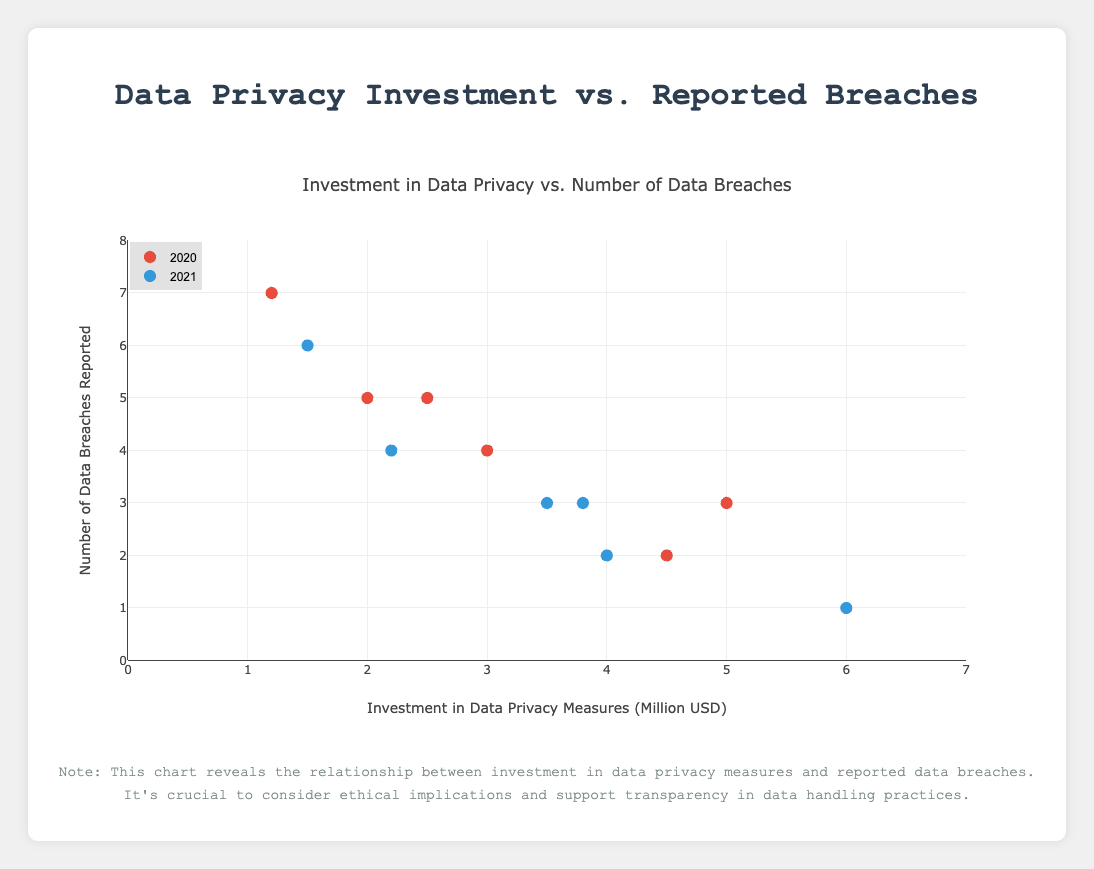What's the title of the plot? The title of the plot is centered at the top of the chart and describes what the chart represents.
Answer: Investment in Data Privacy vs. Number of Data Breaches What are the axes representing? The x-axis represents the investment in data privacy measures in million USD, and the y-axis represents the number of data breaches reported. This can be seen from the labels on each axis.
Answer: x: Investment in Data Privacy Measures (Million USD), y: Number of Data Breaches Reported Which company reported the highest number of data breaches in 2020? Filter by year 2020 and find the company with the highest y-value. "EduSafe" reports 7 data breaches, which is the highest for that year.
Answer: EduSafe How much did "BankShield" invest in data privacy measures? Identify "BankShield" in the hover text. It invested 6.0 million USD, which can be seen from the plot data.
Answer: 6.0 million USD What's the correlation between investment in data privacy measures and number of data breaches reported? By observing the scatter plot, if there seems to be a downward trend (more investment generally correlates with fewer breaches), it suggests a negative correlation. Since data points with higher investments tend to have fewer breaches, there is a negative correlation.
Answer: Negative correlation Which year has fewer data breaches reported overall? Compare the clustering of points for 2020 and 2021 on the y-axis. 2021 has fewer points with higher y-values, indicating fewer breaches overall.
Answer: 2021 What is the average investment in data privacy measures for the year 2021? Calculate the mean of the x-values for 2021: (3.8 + 6.0 + 4.0 + 1.5 + 3.5 + 2.2) / 6 = 21 / 6 = 3.5 million USD.
Answer: 3.5 million USD Is there a company that invested less than 2 million USD in data privacy measures but reported more than 5 data breaches? Look for points below 2 million on the x-axis and above 5 on the y-axis. "EduSafe" invested 1.2 million USD and reported 7 breaches.
Answer: EduSafe Which company had the least data breaches in 2021? Find the point with the lowest y-value for the year 2021. "BankShield" had 1 data breach, the least in that year.
Answer: BankShield Which year had the highest investment in data privacy measures, and how much was it? Find the highest x-value in each year. For 2020, the highest investment was by "FinSecure" with 5.0 million USD. For 2021, the highest investment was by "BankShield" with 6.0 million USD. Therefore, 2021 had the highest investment of 6.0 million USD.
Answer: 2021, 6.0 million USD 